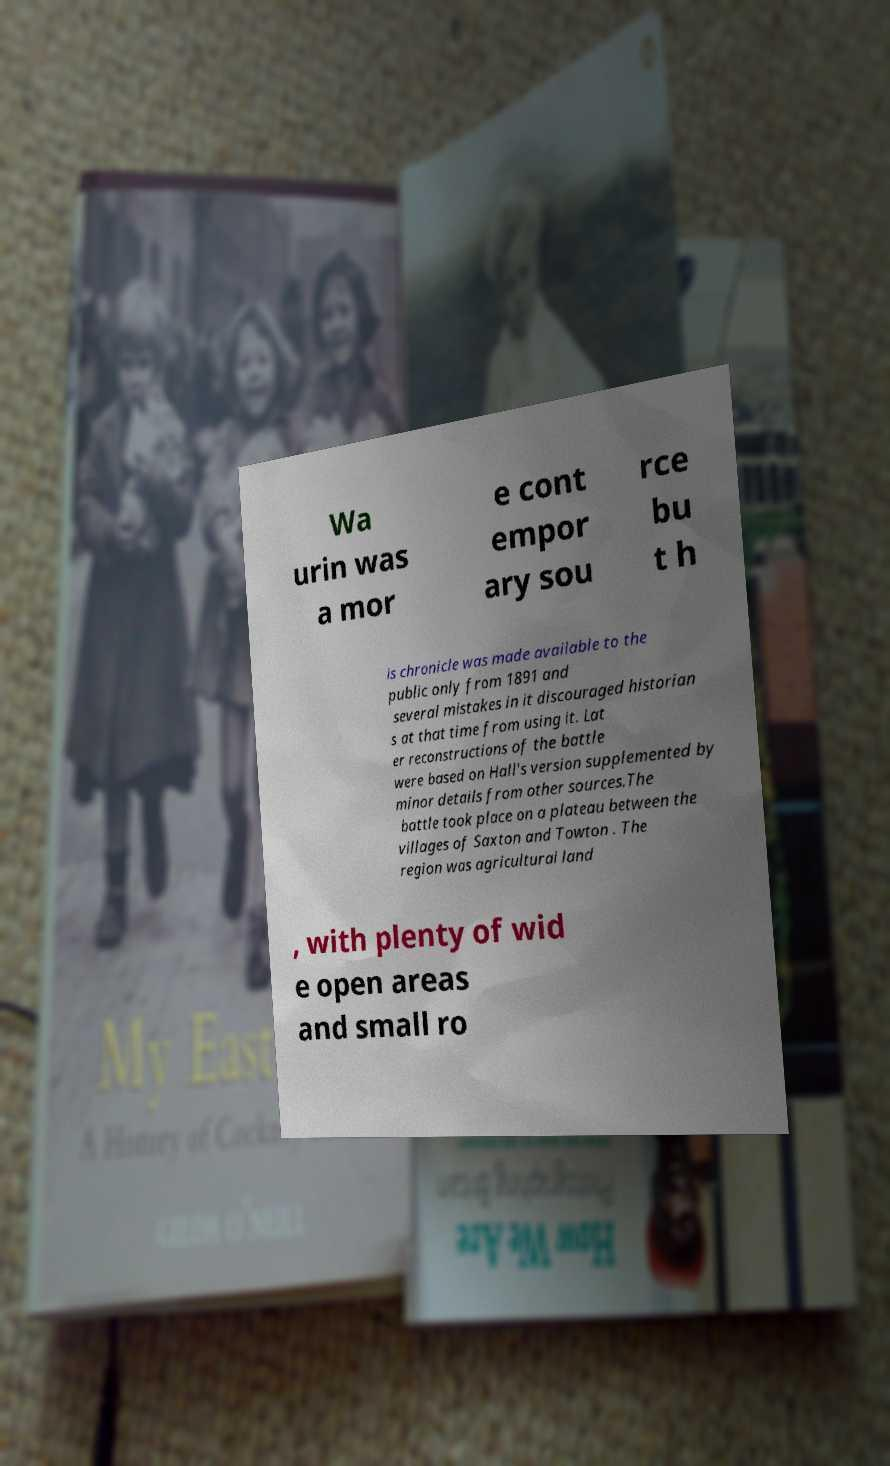Could you extract and type out the text from this image? Wa urin was a mor e cont empor ary sou rce bu t h is chronicle was made available to the public only from 1891 and several mistakes in it discouraged historian s at that time from using it. Lat er reconstructions of the battle were based on Hall's version supplemented by minor details from other sources.The battle took place on a plateau between the villages of Saxton and Towton . The region was agricultural land , with plenty of wid e open areas and small ro 